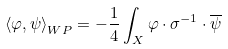Convert formula to latex. <formula><loc_0><loc_0><loc_500><loc_500>\left < \varphi , \psi \right > _ { W P } = - \frac { 1 } { 4 } \int _ { X } \varphi \cdot { \sigma } ^ { - 1 } \cdot \overline { \psi }</formula> 